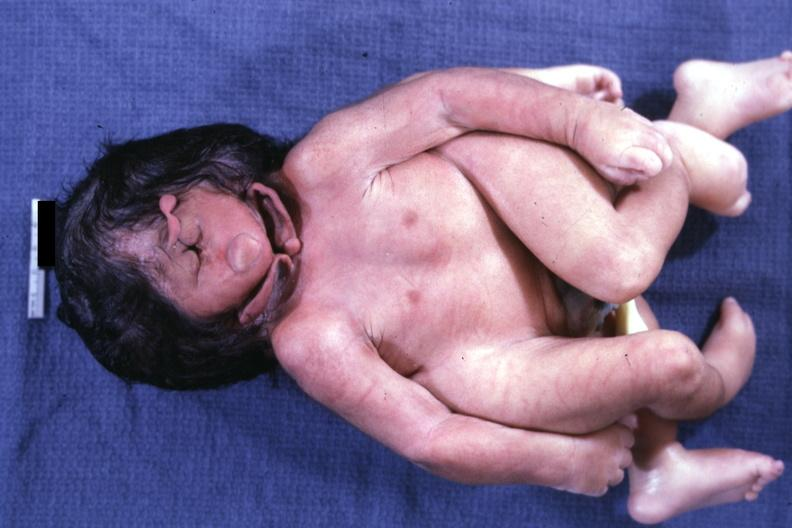s conjoined twins cephalothoracopagus janiceps present?
Answer the question using a single word or phrase. Yes 